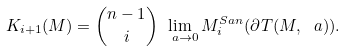<formula> <loc_0><loc_0><loc_500><loc_500>K _ { i + 1 } ( M ) = { n - 1 \choose i } \lim _ { \ a \to 0 } M _ { i } ^ { S a n } ( \partial T ( M , \ a ) ) .</formula> 